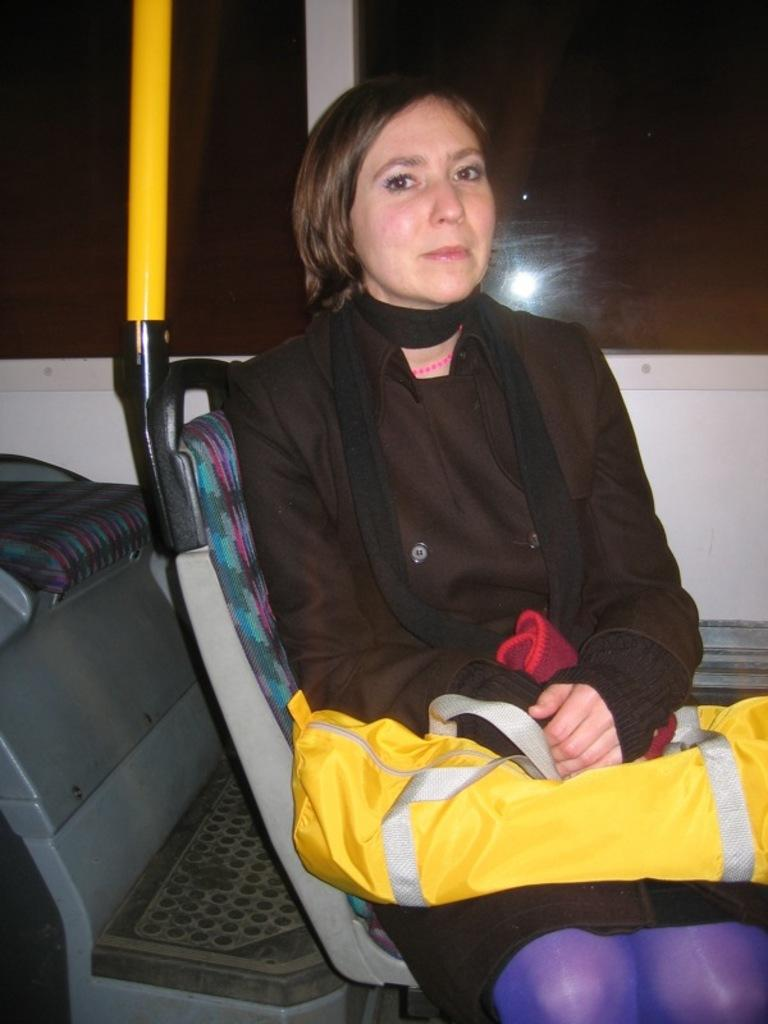Who is present in the image? There is a woman in the image. What is the woman doing in the image? The woman is sitting in a bus. What is the woman holding in her lap? The woman is holding a bag in her lap. What can be seen through the windows in the background of the image? There are glass windows in the background of the image. How many children are playing in the bus in the image? There are no children present in the image; it only shows a woman sitting in a bus. 